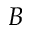<formula> <loc_0><loc_0><loc_500><loc_500>B</formula> 